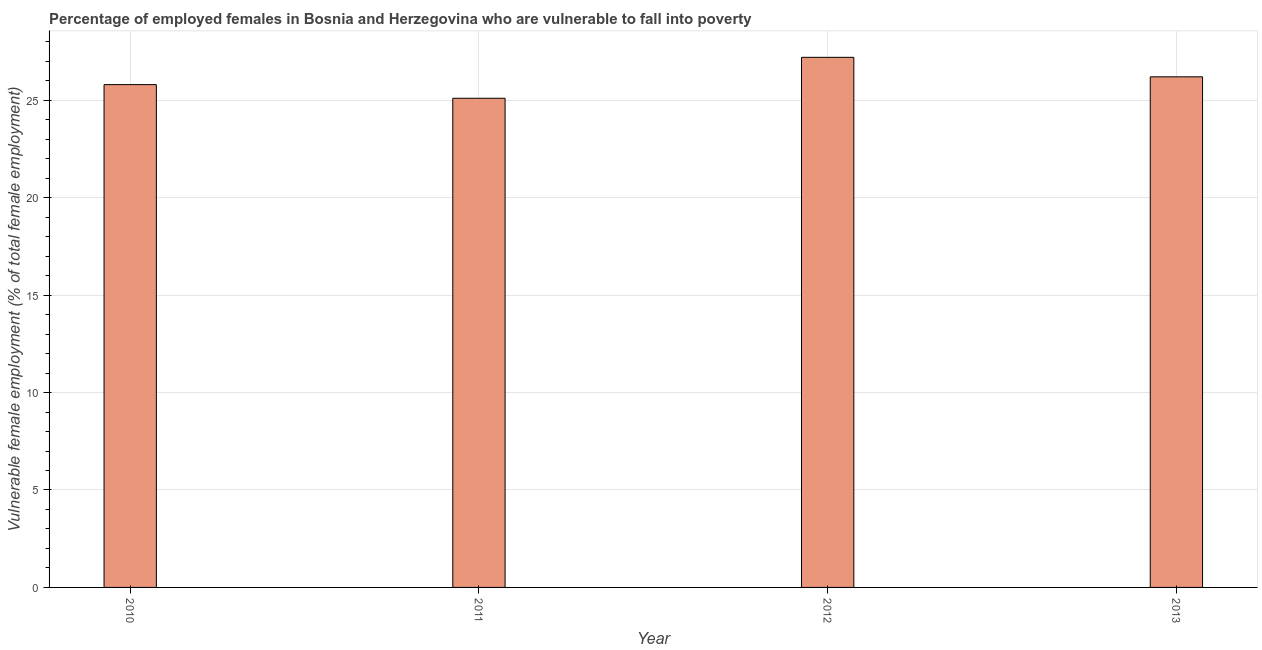Does the graph contain grids?
Provide a succinct answer. Yes. What is the title of the graph?
Provide a succinct answer. Percentage of employed females in Bosnia and Herzegovina who are vulnerable to fall into poverty. What is the label or title of the X-axis?
Your response must be concise. Year. What is the label or title of the Y-axis?
Your response must be concise. Vulnerable female employment (% of total female employment). What is the percentage of employed females who are vulnerable to fall into poverty in 2011?
Keep it short and to the point. 25.1. Across all years, what is the maximum percentage of employed females who are vulnerable to fall into poverty?
Provide a short and direct response. 27.2. Across all years, what is the minimum percentage of employed females who are vulnerable to fall into poverty?
Ensure brevity in your answer.  25.1. In which year was the percentage of employed females who are vulnerable to fall into poverty minimum?
Make the answer very short. 2011. What is the sum of the percentage of employed females who are vulnerable to fall into poverty?
Give a very brief answer. 104.3. What is the difference between the percentage of employed females who are vulnerable to fall into poverty in 2012 and 2013?
Your answer should be compact. 1. What is the average percentage of employed females who are vulnerable to fall into poverty per year?
Provide a succinct answer. 26.07. What is the median percentage of employed females who are vulnerable to fall into poverty?
Provide a succinct answer. 26. What is the difference between the highest and the lowest percentage of employed females who are vulnerable to fall into poverty?
Keep it short and to the point. 2.1. In how many years, is the percentage of employed females who are vulnerable to fall into poverty greater than the average percentage of employed females who are vulnerable to fall into poverty taken over all years?
Keep it short and to the point. 2. How many bars are there?
Offer a very short reply. 4. Are all the bars in the graph horizontal?
Provide a short and direct response. No. Are the values on the major ticks of Y-axis written in scientific E-notation?
Provide a short and direct response. No. What is the Vulnerable female employment (% of total female employment) of 2010?
Keep it short and to the point. 25.8. What is the Vulnerable female employment (% of total female employment) in 2011?
Ensure brevity in your answer.  25.1. What is the Vulnerable female employment (% of total female employment) in 2012?
Ensure brevity in your answer.  27.2. What is the Vulnerable female employment (% of total female employment) in 2013?
Provide a succinct answer. 26.2. What is the difference between the Vulnerable female employment (% of total female employment) in 2010 and 2011?
Make the answer very short. 0.7. What is the difference between the Vulnerable female employment (% of total female employment) in 2010 and 2013?
Ensure brevity in your answer.  -0.4. What is the difference between the Vulnerable female employment (% of total female employment) in 2011 and 2012?
Keep it short and to the point. -2.1. What is the difference between the Vulnerable female employment (% of total female employment) in 2011 and 2013?
Your answer should be compact. -1.1. What is the ratio of the Vulnerable female employment (% of total female employment) in 2010 to that in 2011?
Give a very brief answer. 1.03. What is the ratio of the Vulnerable female employment (% of total female employment) in 2010 to that in 2012?
Your answer should be very brief. 0.95. What is the ratio of the Vulnerable female employment (% of total female employment) in 2010 to that in 2013?
Provide a succinct answer. 0.98. What is the ratio of the Vulnerable female employment (% of total female employment) in 2011 to that in 2012?
Ensure brevity in your answer.  0.92. What is the ratio of the Vulnerable female employment (% of total female employment) in 2011 to that in 2013?
Keep it short and to the point. 0.96. What is the ratio of the Vulnerable female employment (% of total female employment) in 2012 to that in 2013?
Offer a terse response. 1.04. 